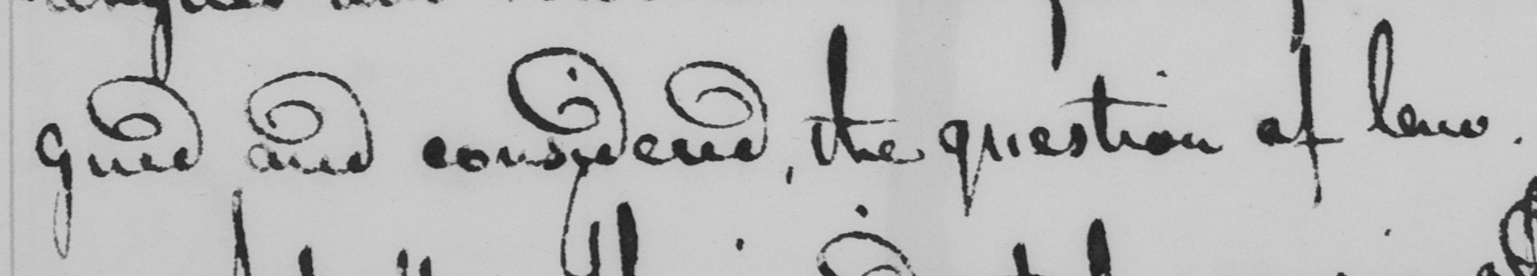Can you read and transcribe this handwriting? gued and considered, the question of law. 